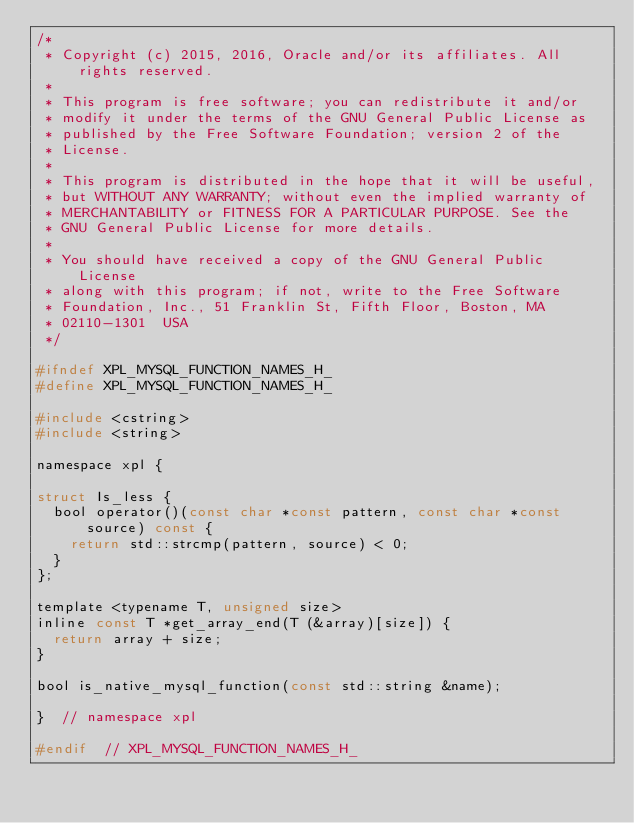<code> <loc_0><loc_0><loc_500><loc_500><_C_>/*
 * Copyright (c) 2015, 2016, Oracle and/or its affiliates. All rights reserved.
 *
 * This program is free software; you can redistribute it and/or
 * modify it under the terms of the GNU General Public License as
 * published by the Free Software Foundation; version 2 of the
 * License.
 *
 * This program is distributed in the hope that it will be useful,
 * but WITHOUT ANY WARRANTY; without even the implied warranty of
 * MERCHANTABILITY or FITNESS FOR A PARTICULAR PURPOSE. See the
 * GNU General Public License for more details.
 *
 * You should have received a copy of the GNU General Public License
 * along with this program; if not, write to the Free Software
 * Foundation, Inc., 51 Franklin St, Fifth Floor, Boston, MA
 * 02110-1301  USA
 */

#ifndef XPL_MYSQL_FUNCTION_NAMES_H_
#define XPL_MYSQL_FUNCTION_NAMES_H_

#include <cstring>
#include <string>

namespace xpl {

struct Is_less {
  bool operator()(const char *const pattern, const char *const source) const {
    return std::strcmp(pattern, source) < 0;
  }
};

template <typename T, unsigned size>
inline const T *get_array_end(T (&array)[size]) {
  return array + size;
}

bool is_native_mysql_function(const std::string &name);

}  // namespace xpl

#endif  // XPL_MYSQL_FUNCTION_NAMES_H_
 </code> 